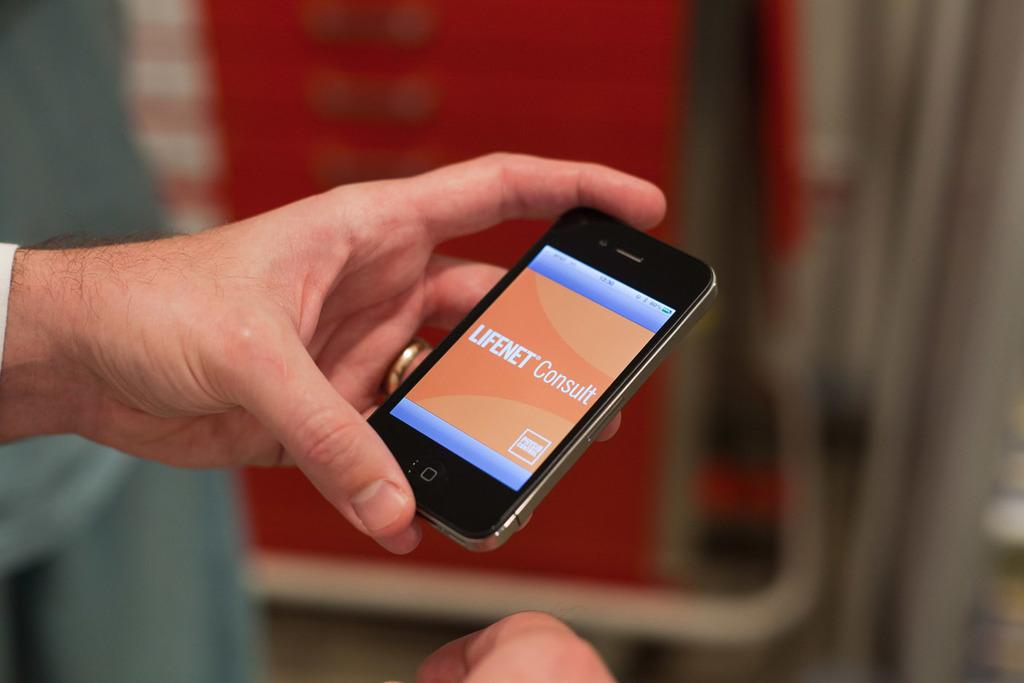What part of a person can be seen in the image? The hands of a person are visible in the image. What is the person holding in the image? The person is holding a mobile in the image. Can you describe the background of the image? The background of the image is blurred. What type of arch can be seen in the background of the image? There is no arch present in the background of the image. Is the person wearing a ring on their finger in the image? The image does not show any rings on the person's fingers. 